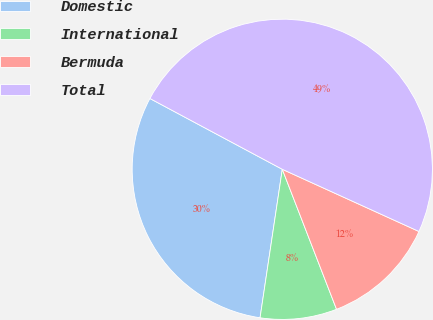Convert chart. <chart><loc_0><loc_0><loc_500><loc_500><pie_chart><fcel>Domestic<fcel>International<fcel>Bermuda<fcel>Total<nl><fcel>30.45%<fcel>8.25%<fcel>12.32%<fcel>48.98%<nl></chart> 